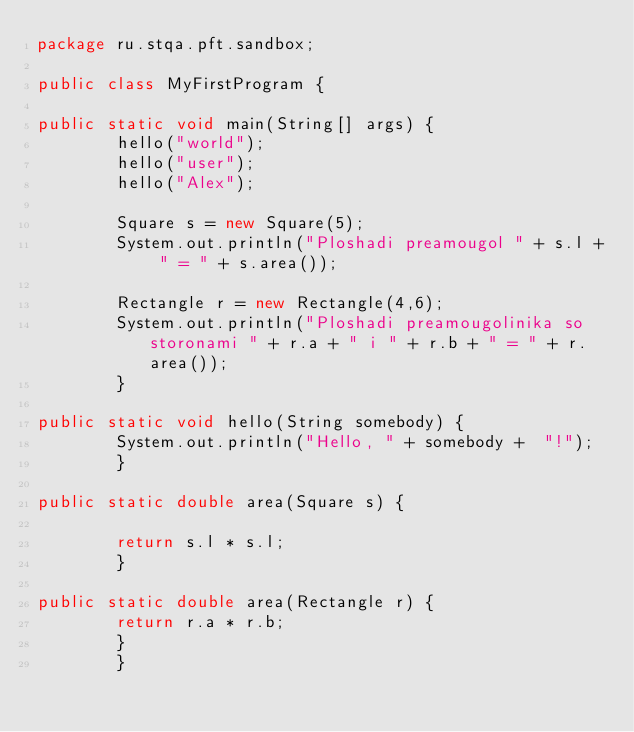Convert code to text. <code><loc_0><loc_0><loc_500><loc_500><_Java_>package ru.stqa.pft.sandbox;

public class MyFirstProgram {

public static void main(String[] args) {
        hello("world");
        hello("user");
        hello("Alex");

        Square s = new Square(5);
        System.out.println("Ploshadi preamougol " + s.l + " = " + s.area());

        Rectangle r = new Rectangle(4,6);
        System.out.println("Ploshadi preamougolinika so storonami " + r.a + " i " + r.b + " = " + r.area());
        }

public static void hello(String somebody) {
        System.out.println("Hello, " + somebody +  "!");
        }

public static double area(Square s) {

        return s.l * s.l;
        }

public static double area(Rectangle r) {
        return r.a * r.b;
        }
        }</code> 